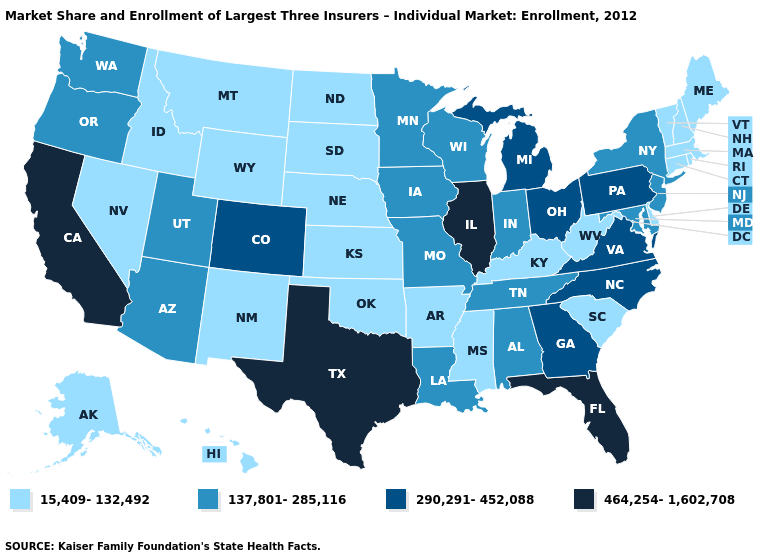Does Washington have the lowest value in the USA?
Be succinct. No. Does Tennessee have the lowest value in the USA?
Give a very brief answer. No. Name the states that have a value in the range 290,291-452,088?
Short answer required. Colorado, Georgia, Michigan, North Carolina, Ohio, Pennsylvania, Virginia. Does the map have missing data?
Be succinct. No. Name the states that have a value in the range 290,291-452,088?
Give a very brief answer. Colorado, Georgia, Michigan, North Carolina, Ohio, Pennsylvania, Virginia. What is the highest value in the West ?
Concise answer only. 464,254-1,602,708. What is the value of Utah?
Short answer required. 137,801-285,116. What is the lowest value in states that border Wyoming?
Write a very short answer. 15,409-132,492. Does Texas have the highest value in the USA?
Concise answer only. Yes. Among the states that border Massachusetts , which have the highest value?
Answer briefly. New York. What is the value of Rhode Island?
Short answer required. 15,409-132,492. Does Alabama have a lower value than Illinois?
Be succinct. Yes. Among the states that border Michigan , does Indiana have the lowest value?
Be succinct. Yes. Does Virginia have the highest value in the USA?
Keep it brief. No. 